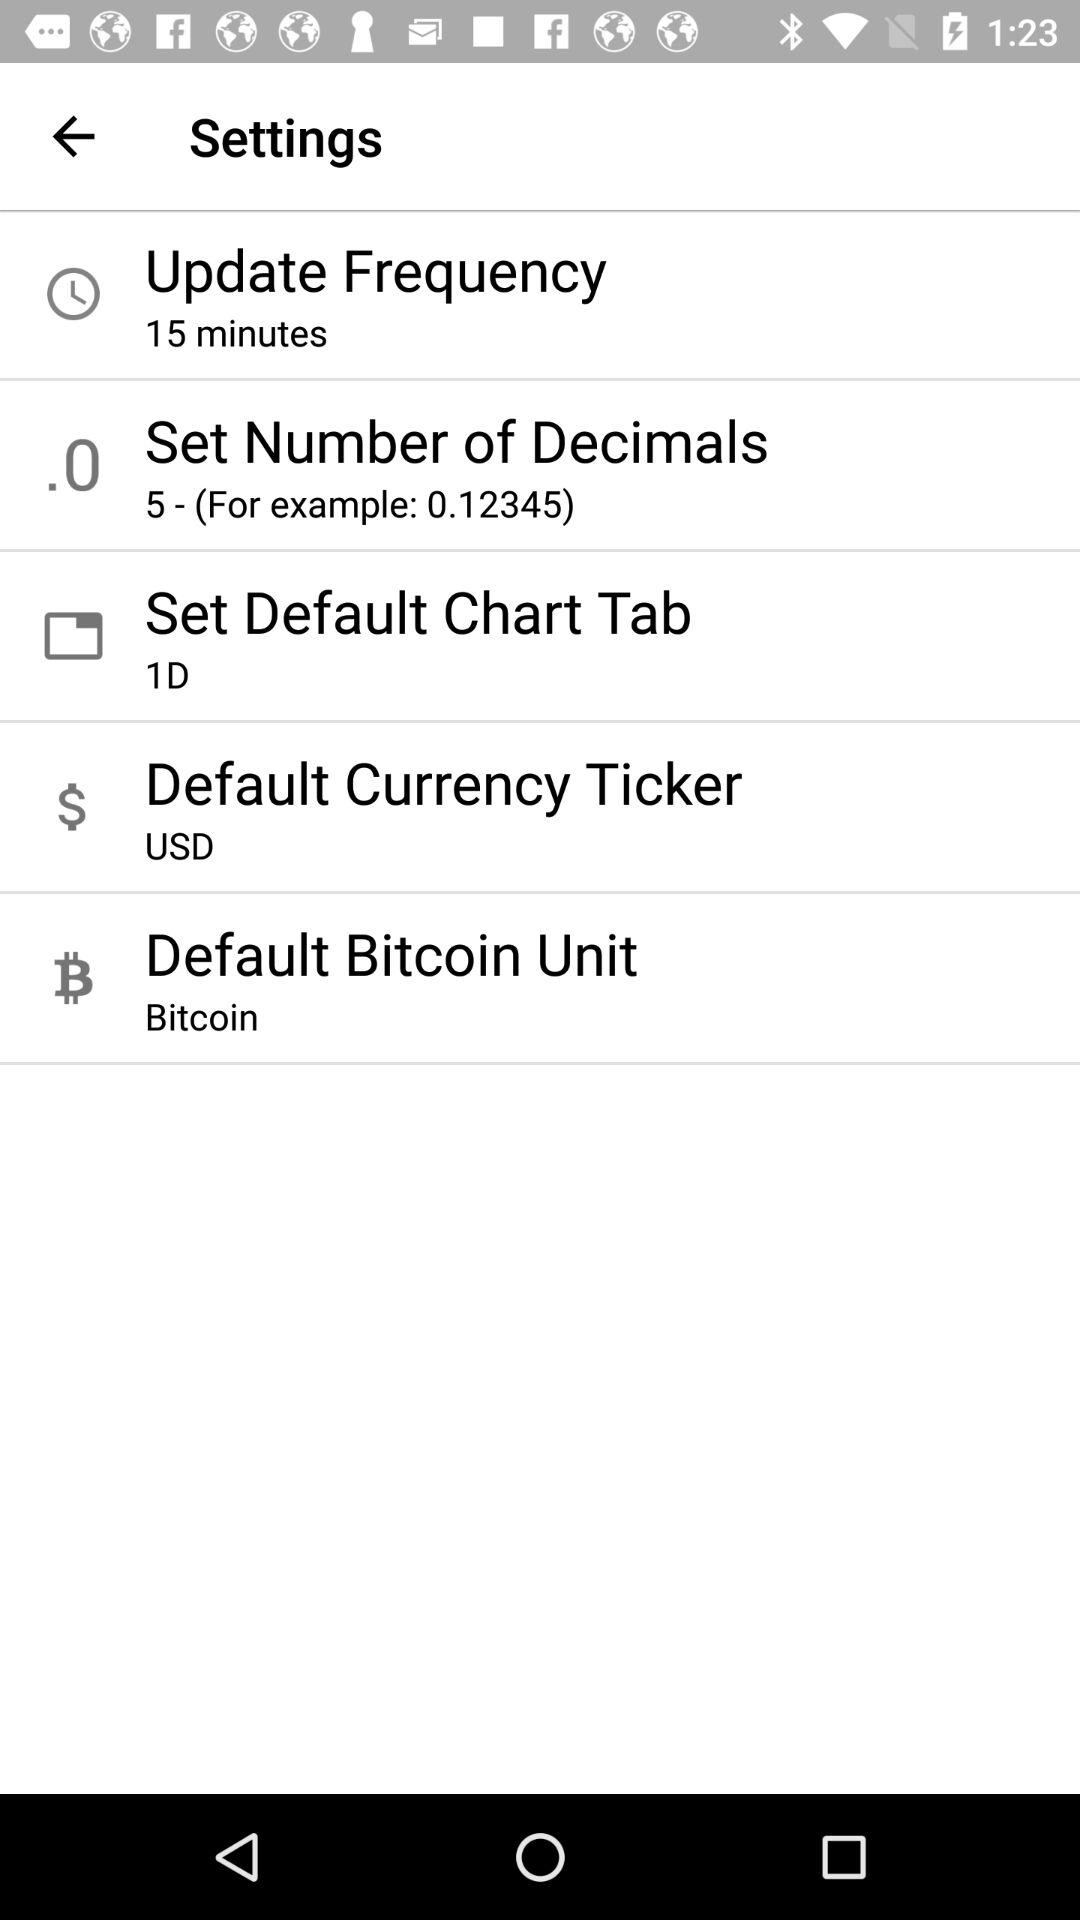How many settings options are there?
Answer the question using a single word or phrase. 5 